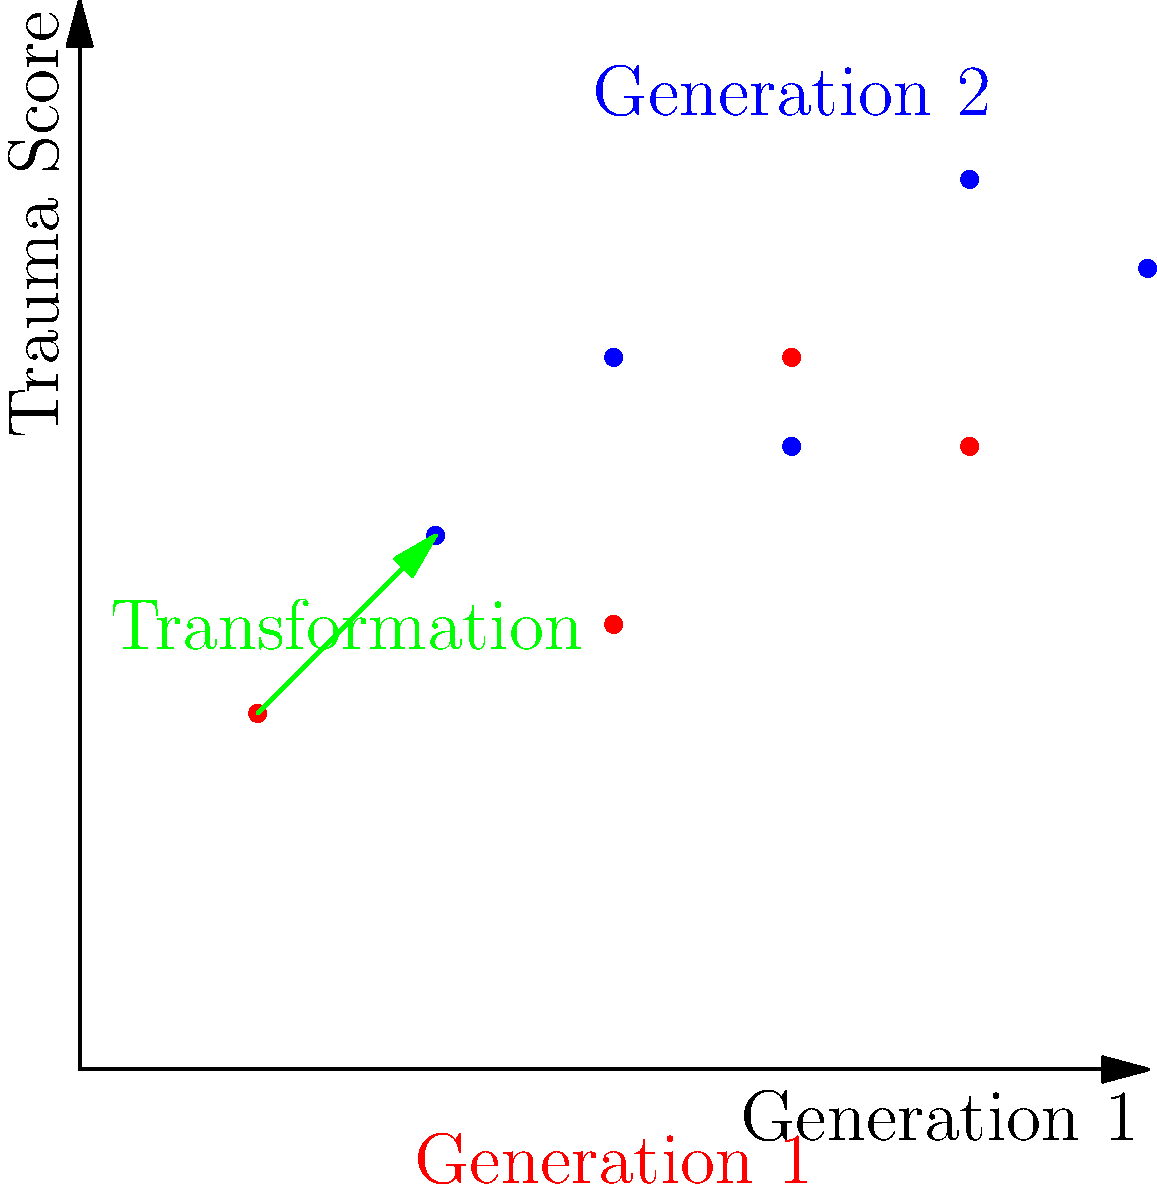In a study on intergenerational trauma, data points representing trauma scores for two generations are plotted. The red points represent Generation 1, and the blue points represent Generation 2. If the transformation from Generation 1 to Generation 2 can be described as a single geometric transformation, what type of transformation is it, and what are its parameters? To determine the type of transformation and its parameters, we need to analyze the relationship between the red points (Generation 1) and the blue points (Generation 2).

Step 1: Observe the pattern between corresponding points.
- Each blue point appears to be shifted relative to its corresponding red point.
- The shift seems to be consistent for all points.

Step 2: Calculate the displacement between corresponding points.
- For any pair of corresponding points, we can see that:
  $x_2 = x_1 + 1$
  $y_2 = y_1 + 1$

Step 3: Identify the transformation type.
- Since all points are shifted by the same amount in both x and y directions, this is a translation.

Step 4: Determine the parameters of the translation.
- The translation vector is $(1, 1)$, as each point is moved 1 unit right and 1 unit up.

Step 5: Verify the transformation.
- We can confirm that applying the translation $T(x, y) = (x+1, y+1)$ to any red point will result in its corresponding blue point.

Step 6: Interpret the results in the context of intergenerational trauma.
- This translation suggests that trauma scores in Generation 2 are consistently higher than those in Generation 1 by a fixed amount, indicating a potential increase in trauma across generations.
Answer: Translation by vector $(1, 1)$ 